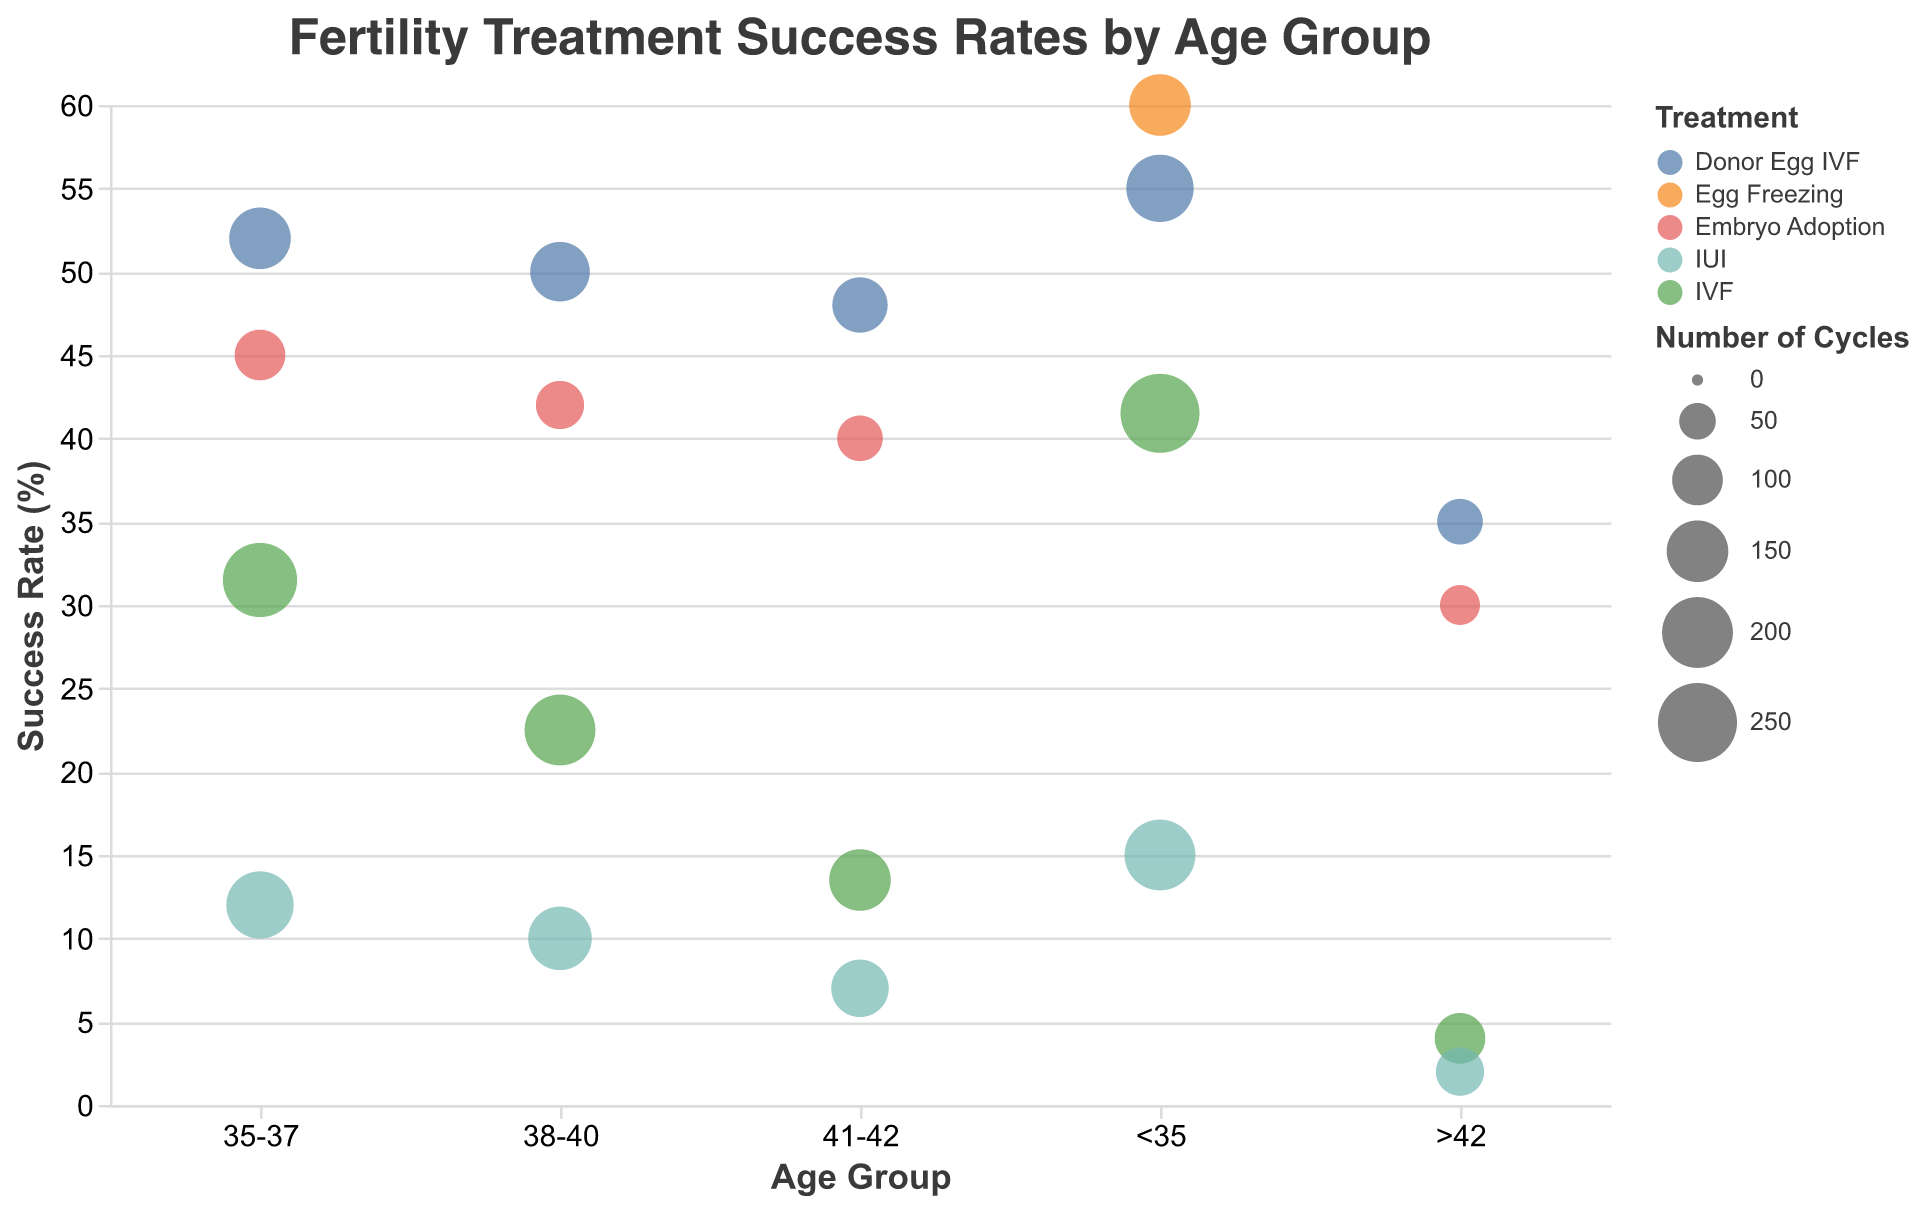What's the title of the plot? The title of the plot is often displayed at the top center. In this plot, the title is "Fertility Treatment Success Rates by Age Group".
Answer: Fertility Treatment Success Rates by Age Group What does the x-axis represent? By looking at the x-axis, we can observe that it indicates different "Age Groups".
Answer: Age Groups Which treatment has the highest success rate for the age group <35? We need to identify the bubble with the highest y-value (Success Rate) within the <35 age group. The treatment corresponding to this bubble is Egg Freezing with a success rate of 60%.
Answer: Egg Freezing What are the axis titles? The x-axis title is "Age Group" as it shows different age groups, and the y-axis title is "Success Rate (%)" as it shows the success rates.
Answer: Age Group, Success Rate (%) Compare the success rates of IVF for the two extreme age groups on the plot. The success rate for IVF in the <35 age group is about 41.5%, while in the >42 age group, it is 4%.
Answer: IVF success rate <35: 41.5%, IVF success rate >42: 4% How does the number of cycles influence the bubble size? The larger the number of cycles, the bigger the bubble. This is evident from the variable bubble sizes corresponding to the "Number of Cycles".
Answer: Bigger bubble = More cycles What is the most expensive treatment per cycle, and how is this depicted in the figure? We look at the "Cost per Cycle" in the tooltip for each bubble. The most expensive treatment is Donor Egg IVF at $35,000 per cycle. This is depicted with larger and often more visible bubbles due to higher treatment usage.
Answer: Donor Egg IVF, $35,000 Among the treatments available for the 38-40 age group, which has the lowest success rate, and what is it? By examining the lowest point on the y-axis within the 38-40 age group, we find IUI with a success rate of 10%.
Answer: IUI, 10% What is the difference in success rates between Embryo Adoption and Donor Egg IVF for the age group 41-42? First, find the success rates of Embryo Adoption (40%) and Donor Egg IVF (48%). Then, subtract the smaller rate from the larger one (48% - 40% = 8%).
Answer: 8% For women older than 42, which treatment offers the highest success rate, and what is it? Look at the highest bubble in the >42 age group; it corresponds to Donor Egg IVF with a success rate of 35%.
Answer: Donor Egg IVF, 35% 